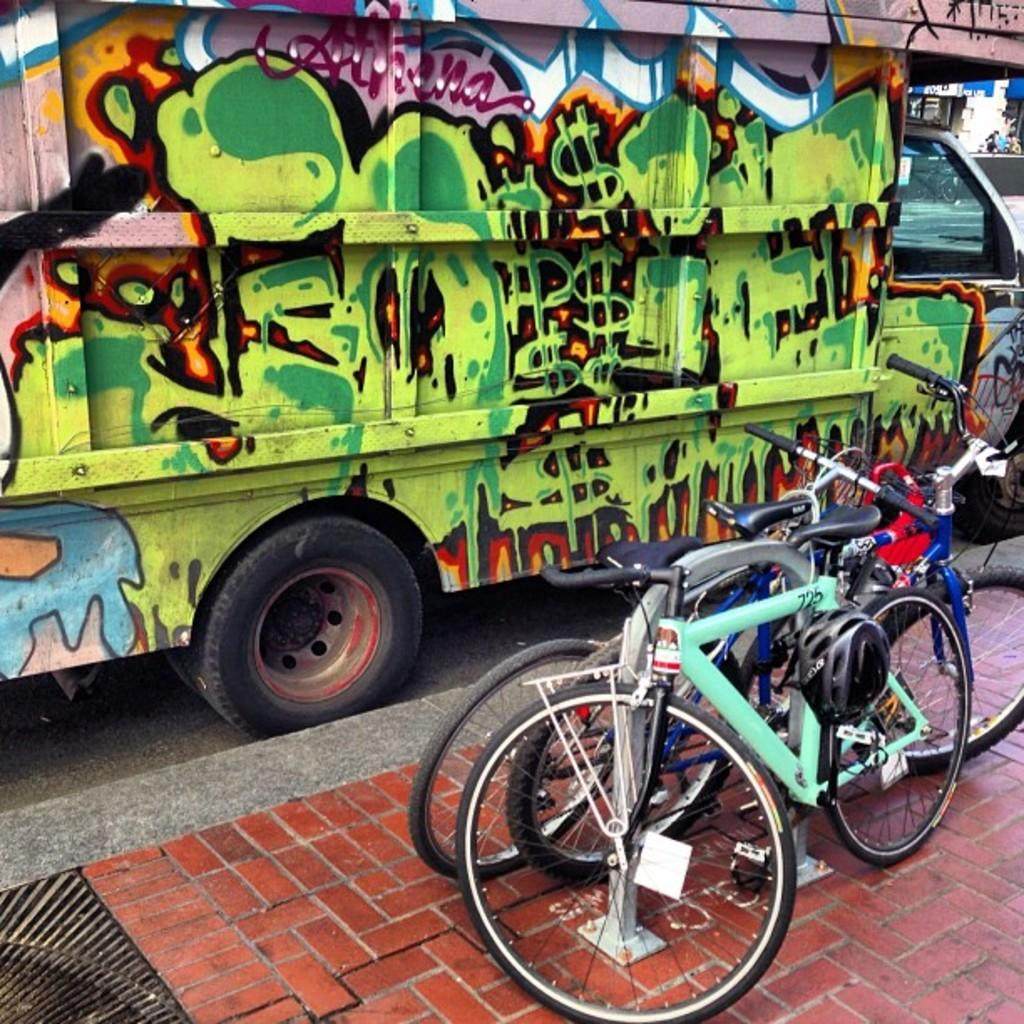What type of transportation can be seen in the image? There are bicycles in the image. What else is present on the ground in the image? There is a vehicle on the ground in the image. What safety equipment is visible in the image? Helmets are visible in the image. What can be seen in the distance in the image? There are objects in the background of the image. What type of yak can be seen grazing in the background of the image? There is no yak present in the image; it features bicycles, a vehicle, helmets, and objects in the background. 